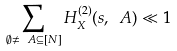Convert formula to latex. <formula><loc_0><loc_0><loc_500><loc_500>\sum _ { \emptyset \neq \ A \subseteq [ N ] } H _ { X } ^ { ( 2 ) } ( s , \ A ) \ll 1</formula> 